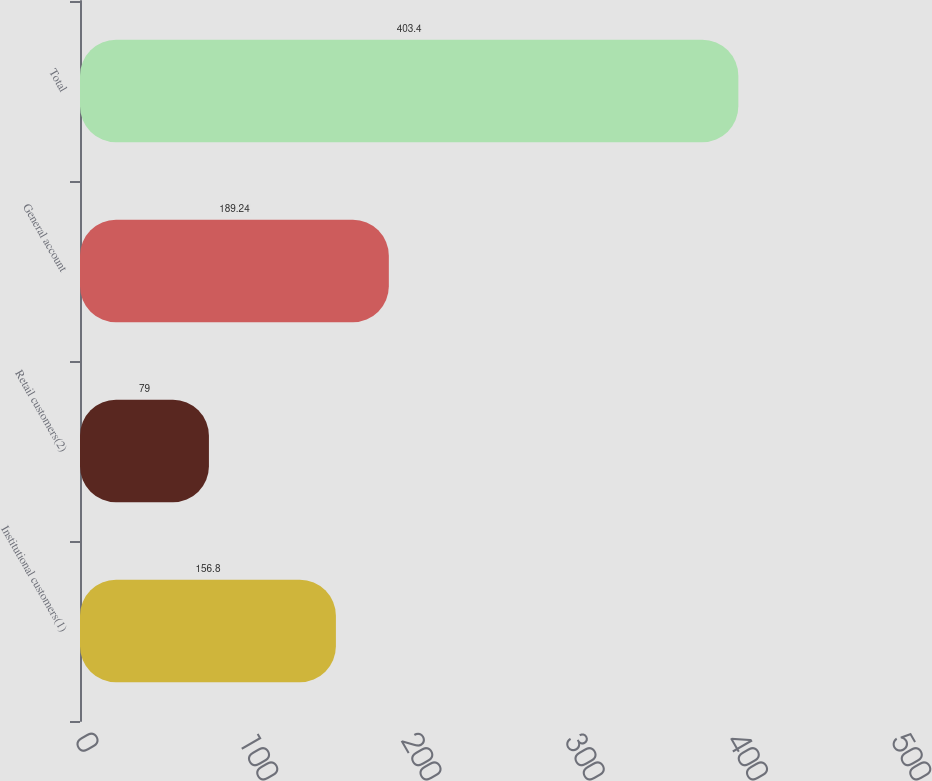Convert chart. <chart><loc_0><loc_0><loc_500><loc_500><bar_chart><fcel>Institutional customers(1)<fcel>Retail customers(2)<fcel>General account<fcel>Total<nl><fcel>156.8<fcel>79<fcel>189.24<fcel>403.4<nl></chart> 